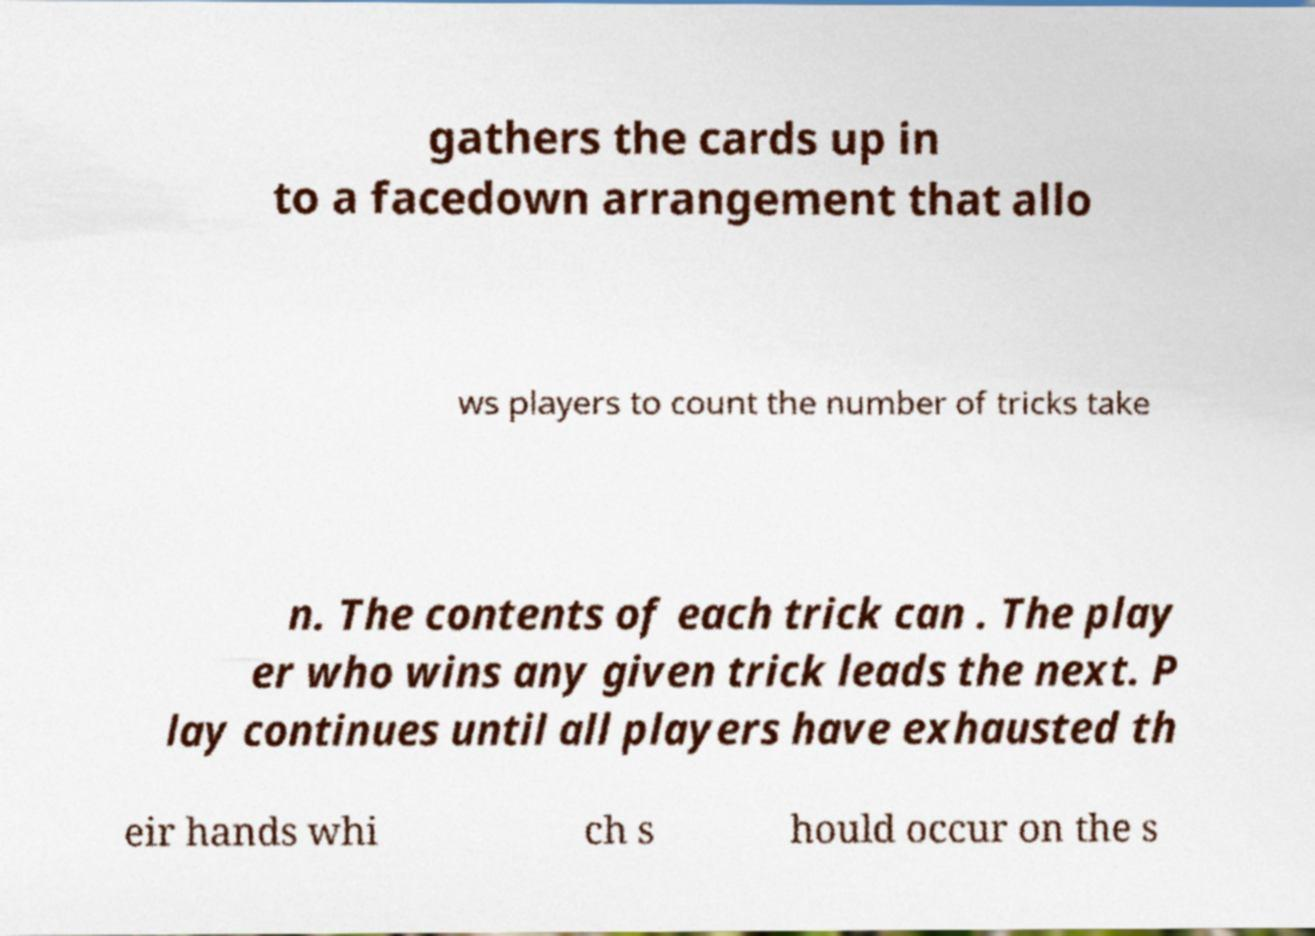Please read and relay the text visible in this image. What does it say? gathers the cards up in to a facedown arrangement that allo ws players to count the number of tricks take n. The contents of each trick can . The play er who wins any given trick leads the next. P lay continues until all players have exhausted th eir hands whi ch s hould occur on the s 